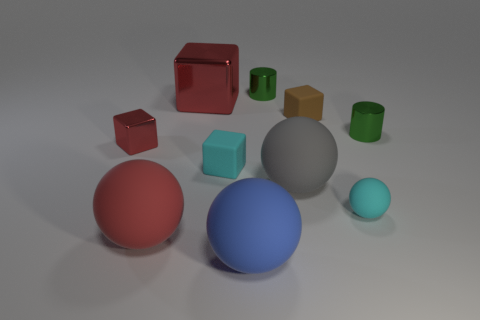Subtract all small red metal cubes. How many cubes are left? 3 Subtract all gray cylinders. How many red cubes are left? 2 Subtract all cyan balls. How many balls are left? 3 Subtract 1 cubes. How many cubes are left? 3 Subtract all blocks. How many objects are left? 6 Add 5 green things. How many green things exist? 7 Subtract 0 purple cylinders. How many objects are left? 10 Subtract all green cubes. Subtract all purple spheres. How many cubes are left? 4 Subtract all big blocks. Subtract all blue objects. How many objects are left? 8 Add 6 cyan rubber objects. How many cyan rubber objects are left? 8 